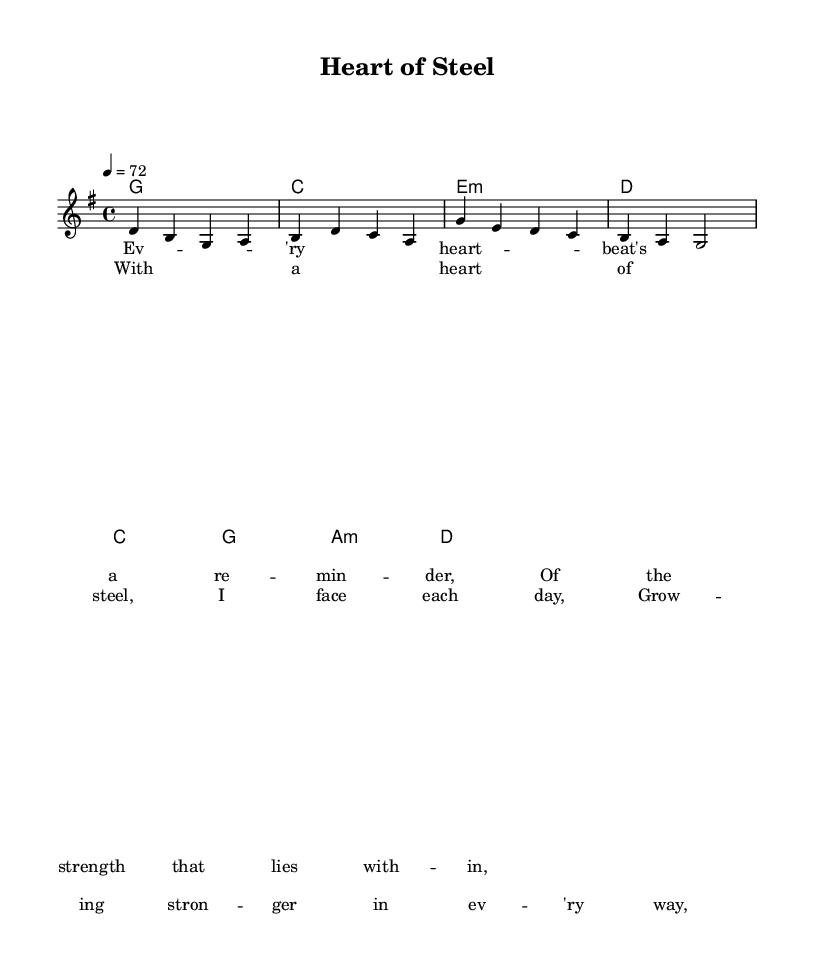What is the key signature of this music? The key signature indicates G major, which contains one sharp (F#). This can be inferred from the global settings in the music sheet.
Answer: G major What is the time signature of this music? The time signature is 4/4, which is noted in the global context of the sheet music. This means there are four beats per measure.
Answer: 4/4 What is the tempo marking for this piece? The tempo marking is set at 72 beats per minute, as indicated by the "tempo 4 = 72" notation in the global settings.
Answer: 72 What is the primary theme of the lyrics? The lyrics discuss resilience and personal growth, emphasizing overcoming adversity with inner strength. This can be understood by analyzing the content of the verses and chorus provided in the sheet music.
Answer: Resilience How many measures are in the verse? The verse consists of 8 measures, which can be counted from the melody section given. Each measure is separated by a bar line, and there are eight distinct phrases before reaching the chorus.
Answer: 8 What is the chord progression in the chorus? The chord progression in the chorus follows a pattern: C, G, A minor, D. This can be determined by examining the chord symbols placed above the melody in the score.
Answer: C, G, A minor, D What stylistic elements identify this as Country Rock? The use of simple, relatable lyrics combined with a strong backbeat and melodic structure is characteristic of Country Rock. These elements are reflected in the lyrical themes and chord progressions present in this piece.
Answer: Relatable lyrics, strong backbeat 